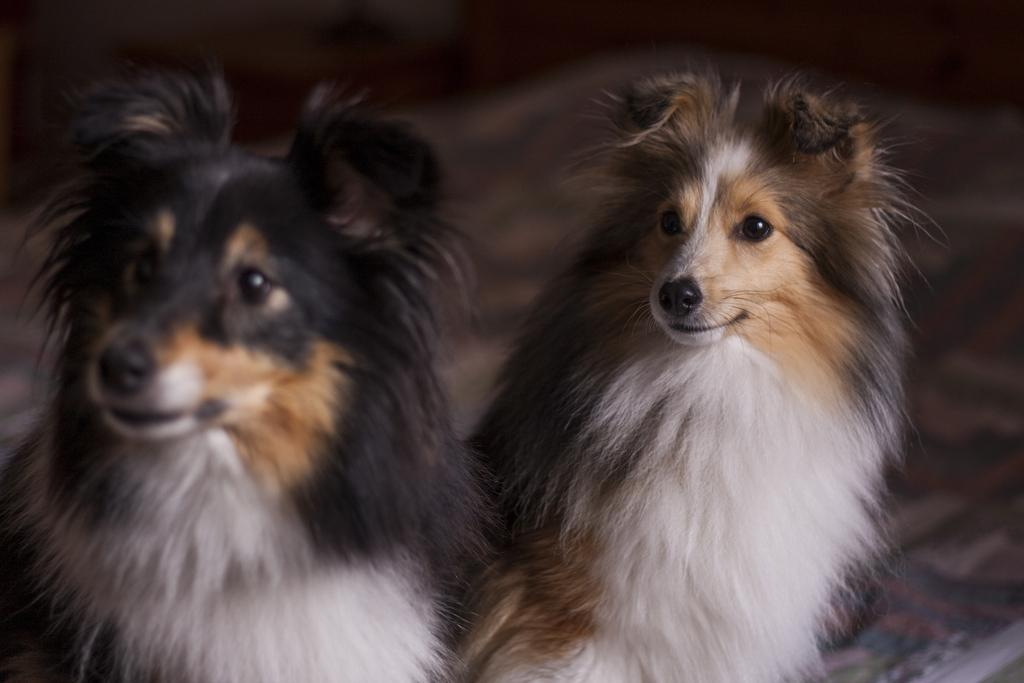How many dogs are present in the image? There are two dogs in the image. Can you describe the background of the image? The background of the image is blurred. What type of light fixture can be seen in the room in the image? There is no room or light fixture present in the image; it features two dogs with a blurred background. 